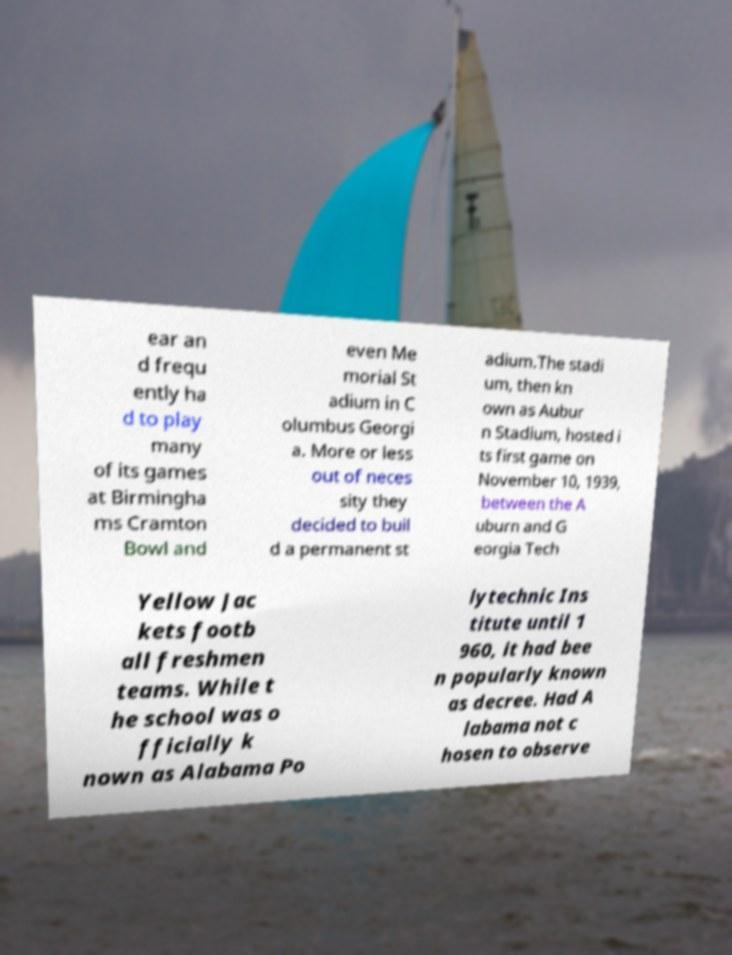Please read and relay the text visible in this image. What does it say? ear an d frequ ently ha d to play many of its games at Birmingha ms Cramton Bowl and even Me morial St adium in C olumbus Georgi a. More or less out of neces sity they decided to buil d a permanent st adium.The stadi um, then kn own as Aubur n Stadium, hosted i ts first game on November 10, 1939, between the A uburn and G eorgia Tech Yellow Jac kets footb all freshmen teams. While t he school was o fficially k nown as Alabama Po lytechnic Ins titute until 1 960, it had bee n popularly known as decree. Had A labama not c hosen to observe 